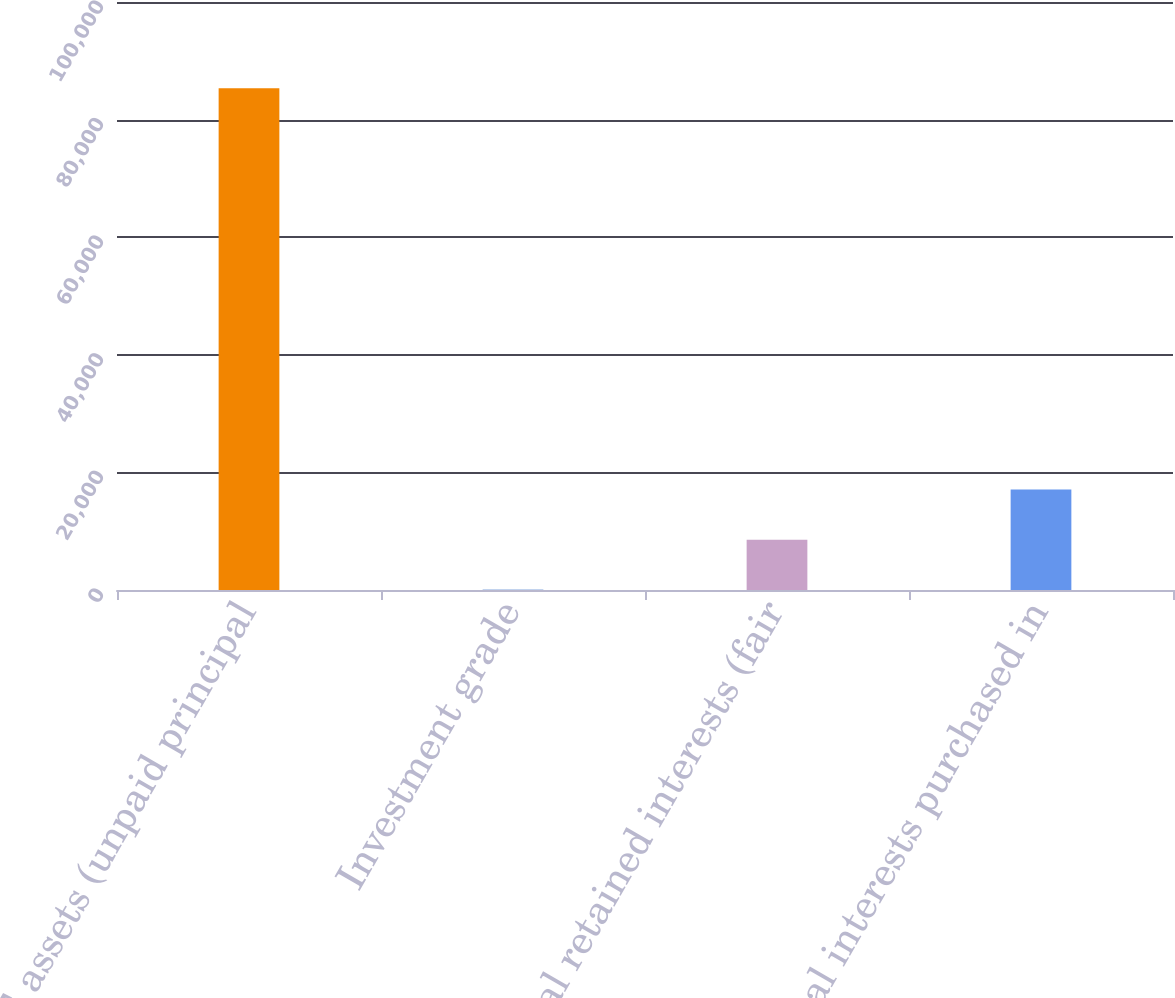<chart> <loc_0><loc_0><loc_500><loc_500><bar_chart><fcel>SPE assets (unpaid principal<fcel>Investment grade<fcel>Total retained interests (fair<fcel>Total interests purchased in<nl><fcel>85333<fcel>22<fcel>8553.1<fcel>17084.2<nl></chart> 